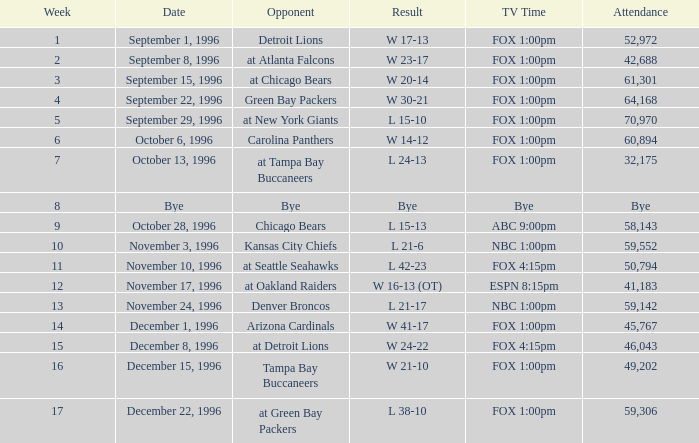Who was the rival on november 24, 1996? Denver Broncos. 